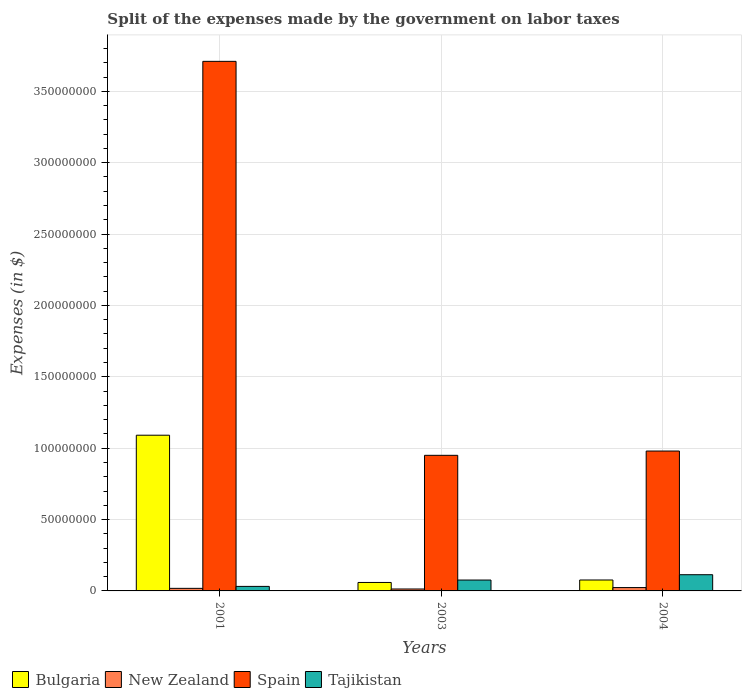How many groups of bars are there?
Provide a short and direct response. 3. How many bars are there on the 2nd tick from the right?
Offer a terse response. 4. What is the label of the 3rd group of bars from the left?
Offer a very short reply. 2004. What is the expenses made by the government on labor taxes in New Zealand in 2001?
Ensure brevity in your answer.  1.80e+06. Across all years, what is the maximum expenses made by the government on labor taxes in Tajikistan?
Your response must be concise. 1.14e+07. Across all years, what is the minimum expenses made by the government on labor taxes in New Zealand?
Offer a terse response. 1.36e+06. In which year was the expenses made by the government on labor taxes in Tajikistan minimum?
Offer a very short reply. 2001. What is the total expenses made by the government on labor taxes in Spain in the graph?
Give a very brief answer. 5.64e+08. What is the difference between the expenses made by the government on labor taxes in Spain in 2001 and the expenses made by the government on labor taxes in Bulgaria in 2004?
Offer a very short reply. 3.63e+08. What is the average expenses made by the government on labor taxes in Tajikistan per year?
Make the answer very short. 7.38e+06. In the year 2004, what is the difference between the expenses made by the government on labor taxes in New Zealand and expenses made by the government on labor taxes in Tajikistan?
Your answer should be very brief. -9.01e+06. What is the ratio of the expenses made by the government on labor taxes in Bulgaria in 2001 to that in 2004?
Make the answer very short. 14.26. Is the expenses made by the government on labor taxes in Spain in 2001 less than that in 2004?
Your response must be concise. No. What is the difference between the highest and the second highest expenses made by the government on labor taxes in Bulgaria?
Provide a short and direct response. 1.01e+08. What is the difference between the highest and the lowest expenses made by the government on labor taxes in Bulgaria?
Your answer should be compact. 1.03e+08. Is it the case that in every year, the sum of the expenses made by the government on labor taxes in New Zealand and expenses made by the government on labor taxes in Tajikistan is greater than the expenses made by the government on labor taxes in Spain?
Give a very brief answer. No. What is the difference between two consecutive major ticks on the Y-axis?
Your answer should be very brief. 5.00e+07. Are the values on the major ticks of Y-axis written in scientific E-notation?
Ensure brevity in your answer.  No. Does the graph contain grids?
Your answer should be very brief. Yes. Where does the legend appear in the graph?
Your response must be concise. Bottom left. How many legend labels are there?
Keep it short and to the point. 4. What is the title of the graph?
Ensure brevity in your answer.  Split of the expenses made by the government on labor taxes. What is the label or title of the Y-axis?
Make the answer very short. Expenses (in $). What is the Expenses (in $) in Bulgaria in 2001?
Your answer should be compact. 1.09e+08. What is the Expenses (in $) of New Zealand in 2001?
Your answer should be compact. 1.80e+06. What is the Expenses (in $) in Spain in 2001?
Give a very brief answer. 3.71e+08. What is the Expenses (in $) of Tajikistan in 2001?
Ensure brevity in your answer.  3.17e+06. What is the Expenses (in $) of Bulgaria in 2003?
Provide a succinct answer. 5.93e+06. What is the Expenses (in $) of New Zealand in 2003?
Ensure brevity in your answer.  1.36e+06. What is the Expenses (in $) in Spain in 2003?
Make the answer very short. 9.50e+07. What is the Expenses (in $) in Tajikistan in 2003?
Make the answer very short. 7.63e+06. What is the Expenses (in $) in Bulgaria in 2004?
Keep it short and to the point. 7.65e+06. What is the Expenses (in $) of New Zealand in 2004?
Provide a succinct answer. 2.35e+06. What is the Expenses (in $) of Spain in 2004?
Your answer should be very brief. 9.80e+07. What is the Expenses (in $) of Tajikistan in 2004?
Make the answer very short. 1.14e+07. Across all years, what is the maximum Expenses (in $) in Bulgaria?
Provide a short and direct response. 1.09e+08. Across all years, what is the maximum Expenses (in $) in New Zealand?
Your response must be concise. 2.35e+06. Across all years, what is the maximum Expenses (in $) in Spain?
Offer a terse response. 3.71e+08. Across all years, what is the maximum Expenses (in $) of Tajikistan?
Provide a short and direct response. 1.14e+07. Across all years, what is the minimum Expenses (in $) in Bulgaria?
Give a very brief answer. 5.93e+06. Across all years, what is the minimum Expenses (in $) in New Zealand?
Your response must be concise. 1.36e+06. Across all years, what is the minimum Expenses (in $) of Spain?
Provide a short and direct response. 9.50e+07. Across all years, what is the minimum Expenses (in $) in Tajikistan?
Provide a succinct answer. 3.17e+06. What is the total Expenses (in $) in Bulgaria in the graph?
Give a very brief answer. 1.23e+08. What is the total Expenses (in $) of New Zealand in the graph?
Offer a terse response. 5.50e+06. What is the total Expenses (in $) of Spain in the graph?
Provide a succinct answer. 5.64e+08. What is the total Expenses (in $) of Tajikistan in the graph?
Provide a short and direct response. 2.22e+07. What is the difference between the Expenses (in $) in Bulgaria in 2001 and that in 2003?
Ensure brevity in your answer.  1.03e+08. What is the difference between the Expenses (in $) in New Zealand in 2001 and that in 2003?
Your answer should be compact. 4.44e+05. What is the difference between the Expenses (in $) of Spain in 2001 and that in 2003?
Ensure brevity in your answer.  2.76e+08. What is the difference between the Expenses (in $) in Tajikistan in 2001 and that in 2003?
Provide a succinct answer. -4.46e+06. What is the difference between the Expenses (in $) of Bulgaria in 2001 and that in 2004?
Keep it short and to the point. 1.01e+08. What is the difference between the Expenses (in $) in New Zealand in 2001 and that in 2004?
Your answer should be compact. -5.49e+05. What is the difference between the Expenses (in $) of Spain in 2001 and that in 2004?
Provide a short and direct response. 2.73e+08. What is the difference between the Expenses (in $) of Tajikistan in 2001 and that in 2004?
Keep it short and to the point. -8.18e+06. What is the difference between the Expenses (in $) in Bulgaria in 2003 and that in 2004?
Make the answer very short. -1.72e+06. What is the difference between the Expenses (in $) of New Zealand in 2003 and that in 2004?
Provide a short and direct response. -9.93e+05. What is the difference between the Expenses (in $) of Spain in 2003 and that in 2004?
Provide a succinct answer. -3.00e+06. What is the difference between the Expenses (in $) in Tajikistan in 2003 and that in 2004?
Keep it short and to the point. -3.73e+06. What is the difference between the Expenses (in $) of Bulgaria in 2001 and the Expenses (in $) of New Zealand in 2003?
Offer a terse response. 1.08e+08. What is the difference between the Expenses (in $) in Bulgaria in 2001 and the Expenses (in $) in Spain in 2003?
Provide a succinct answer. 1.41e+07. What is the difference between the Expenses (in $) in Bulgaria in 2001 and the Expenses (in $) in Tajikistan in 2003?
Provide a short and direct response. 1.01e+08. What is the difference between the Expenses (in $) of New Zealand in 2001 and the Expenses (in $) of Spain in 2003?
Your answer should be compact. -9.32e+07. What is the difference between the Expenses (in $) of New Zealand in 2001 and the Expenses (in $) of Tajikistan in 2003?
Your answer should be compact. -5.83e+06. What is the difference between the Expenses (in $) in Spain in 2001 and the Expenses (in $) in Tajikistan in 2003?
Your answer should be very brief. 3.63e+08. What is the difference between the Expenses (in $) in Bulgaria in 2001 and the Expenses (in $) in New Zealand in 2004?
Offer a terse response. 1.07e+08. What is the difference between the Expenses (in $) of Bulgaria in 2001 and the Expenses (in $) of Spain in 2004?
Offer a terse response. 1.11e+07. What is the difference between the Expenses (in $) in Bulgaria in 2001 and the Expenses (in $) in Tajikistan in 2004?
Your answer should be compact. 9.77e+07. What is the difference between the Expenses (in $) in New Zealand in 2001 and the Expenses (in $) in Spain in 2004?
Your answer should be very brief. -9.62e+07. What is the difference between the Expenses (in $) in New Zealand in 2001 and the Expenses (in $) in Tajikistan in 2004?
Provide a succinct answer. -9.56e+06. What is the difference between the Expenses (in $) of Spain in 2001 and the Expenses (in $) of Tajikistan in 2004?
Ensure brevity in your answer.  3.60e+08. What is the difference between the Expenses (in $) in Bulgaria in 2003 and the Expenses (in $) in New Zealand in 2004?
Provide a short and direct response. 3.58e+06. What is the difference between the Expenses (in $) of Bulgaria in 2003 and the Expenses (in $) of Spain in 2004?
Give a very brief answer. -9.21e+07. What is the difference between the Expenses (in $) in Bulgaria in 2003 and the Expenses (in $) in Tajikistan in 2004?
Your answer should be compact. -5.43e+06. What is the difference between the Expenses (in $) of New Zealand in 2003 and the Expenses (in $) of Spain in 2004?
Ensure brevity in your answer.  -9.66e+07. What is the difference between the Expenses (in $) of New Zealand in 2003 and the Expenses (in $) of Tajikistan in 2004?
Give a very brief answer. -1.00e+07. What is the difference between the Expenses (in $) of Spain in 2003 and the Expenses (in $) of Tajikistan in 2004?
Provide a short and direct response. 8.36e+07. What is the average Expenses (in $) of Bulgaria per year?
Provide a succinct answer. 4.09e+07. What is the average Expenses (in $) of New Zealand per year?
Give a very brief answer. 1.84e+06. What is the average Expenses (in $) in Spain per year?
Your answer should be compact. 1.88e+08. What is the average Expenses (in $) in Tajikistan per year?
Your answer should be very brief. 7.38e+06. In the year 2001, what is the difference between the Expenses (in $) of Bulgaria and Expenses (in $) of New Zealand?
Offer a terse response. 1.07e+08. In the year 2001, what is the difference between the Expenses (in $) of Bulgaria and Expenses (in $) of Spain?
Your answer should be very brief. -2.62e+08. In the year 2001, what is the difference between the Expenses (in $) of Bulgaria and Expenses (in $) of Tajikistan?
Make the answer very short. 1.06e+08. In the year 2001, what is the difference between the Expenses (in $) in New Zealand and Expenses (in $) in Spain?
Offer a terse response. -3.69e+08. In the year 2001, what is the difference between the Expenses (in $) in New Zealand and Expenses (in $) in Tajikistan?
Ensure brevity in your answer.  -1.37e+06. In the year 2001, what is the difference between the Expenses (in $) in Spain and Expenses (in $) in Tajikistan?
Offer a very short reply. 3.68e+08. In the year 2003, what is the difference between the Expenses (in $) of Bulgaria and Expenses (in $) of New Zealand?
Give a very brief answer. 4.57e+06. In the year 2003, what is the difference between the Expenses (in $) in Bulgaria and Expenses (in $) in Spain?
Give a very brief answer. -8.91e+07. In the year 2003, what is the difference between the Expenses (in $) of Bulgaria and Expenses (in $) of Tajikistan?
Offer a terse response. -1.70e+06. In the year 2003, what is the difference between the Expenses (in $) of New Zealand and Expenses (in $) of Spain?
Provide a succinct answer. -9.36e+07. In the year 2003, what is the difference between the Expenses (in $) of New Zealand and Expenses (in $) of Tajikistan?
Make the answer very short. -6.27e+06. In the year 2003, what is the difference between the Expenses (in $) in Spain and Expenses (in $) in Tajikistan?
Your answer should be very brief. 8.74e+07. In the year 2004, what is the difference between the Expenses (in $) in Bulgaria and Expenses (in $) in New Zealand?
Provide a short and direct response. 5.30e+06. In the year 2004, what is the difference between the Expenses (in $) of Bulgaria and Expenses (in $) of Spain?
Your answer should be very brief. -9.03e+07. In the year 2004, what is the difference between the Expenses (in $) in Bulgaria and Expenses (in $) in Tajikistan?
Provide a short and direct response. -3.70e+06. In the year 2004, what is the difference between the Expenses (in $) in New Zealand and Expenses (in $) in Spain?
Offer a terse response. -9.57e+07. In the year 2004, what is the difference between the Expenses (in $) in New Zealand and Expenses (in $) in Tajikistan?
Provide a succinct answer. -9.01e+06. In the year 2004, what is the difference between the Expenses (in $) of Spain and Expenses (in $) of Tajikistan?
Your answer should be very brief. 8.66e+07. What is the ratio of the Expenses (in $) of Bulgaria in 2001 to that in 2003?
Provide a succinct answer. 18.4. What is the ratio of the Expenses (in $) of New Zealand in 2001 to that in 2003?
Offer a terse response. 1.33. What is the ratio of the Expenses (in $) in Spain in 2001 to that in 2003?
Your response must be concise. 3.91. What is the ratio of the Expenses (in $) of Tajikistan in 2001 to that in 2003?
Your answer should be compact. 0.42. What is the ratio of the Expenses (in $) of Bulgaria in 2001 to that in 2004?
Offer a very short reply. 14.26. What is the ratio of the Expenses (in $) of New Zealand in 2001 to that in 2004?
Your response must be concise. 0.77. What is the ratio of the Expenses (in $) of Spain in 2001 to that in 2004?
Provide a succinct answer. 3.79. What is the ratio of the Expenses (in $) of Tajikistan in 2001 to that in 2004?
Keep it short and to the point. 0.28. What is the ratio of the Expenses (in $) of Bulgaria in 2003 to that in 2004?
Offer a terse response. 0.77. What is the ratio of the Expenses (in $) in New Zealand in 2003 to that in 2004?
Make the answer very short. 0.58. What is the ratio of the Expenses (in $) of Spain in 2003 to that in 2004?
Provide a succinct answer. 0.97. What is the ratio of the Expenses (in $) of Tajikistan in 2003 to that in 2004?
Keep it short and to the point. 0.67. What is the difference between the highest and the second highest Expenses (in $) in Bulgaria?
Your answer should be compact. 1.01e+08. What is the difference between the highest and the second highest Expenses (in $) in New Zealand?
Offer a very short reply. 5.49e+05. What is the difference between the highest and the second highest Expenses (in $) in Spain?
Keep it short and to the point. 2.73e+08. What is the difference between the highest and the second highest Expenses (in $) in Tajikistan?
Provide a short and direct response. 3.73e+06. What is the difference between the highest and the lowest Expenses (in $) of Bulgaria?
Ensure brevity in your answer.  1.03e+08. What is the difference between the highest and the lowest Expenses (in $) of New Zealand?
Offer a very short reply. 9.93e+05. What is the difference between the highest and the lowest Expenses (in $) of Spain?
Make the answer very short. 2.76e+08. What is the difference between the highest and the lowest Expenses (in $) in Tajikistan?
Your response must be concise. 8.18e+06. 